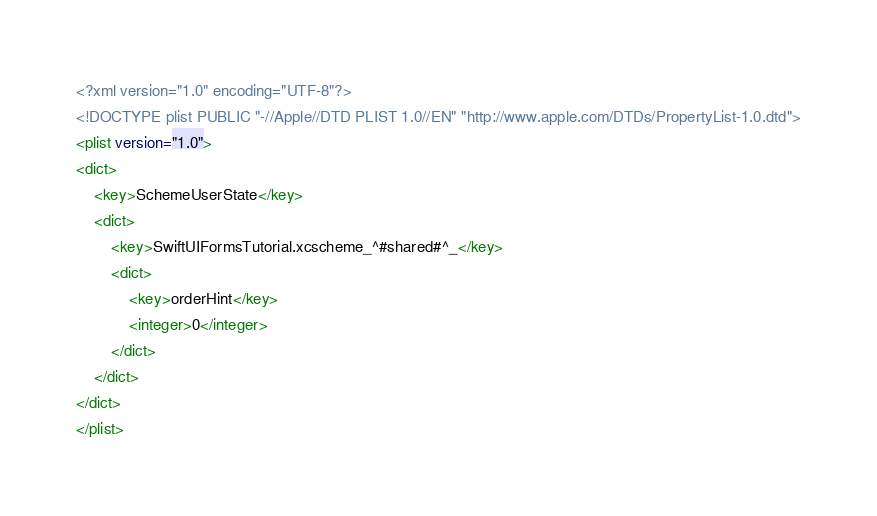Convert code to text. <code><loc_0><loc_0><loc_500><loc_500><_XML_><?xml version="1.0" encoding="UTF-8"?>
<!DOCTYPE plist PUBLIC "-//Apple//DTD PLIST 1.0//EN" "http://www.apple.com/DTDs/PropertyList-1.0.dtd">
<plist version="1.0">
<dict>
	<key>SchemeUserState</key>
	<dict>
		<key>SwiftUIFormsTutorial.xcscheme_^#shared#^_</key>
		<dict>
			<key>orderHint</key>
			<integer>0</integer>
		</dict>
	</dict>
</dict>
</plist>
</code> 